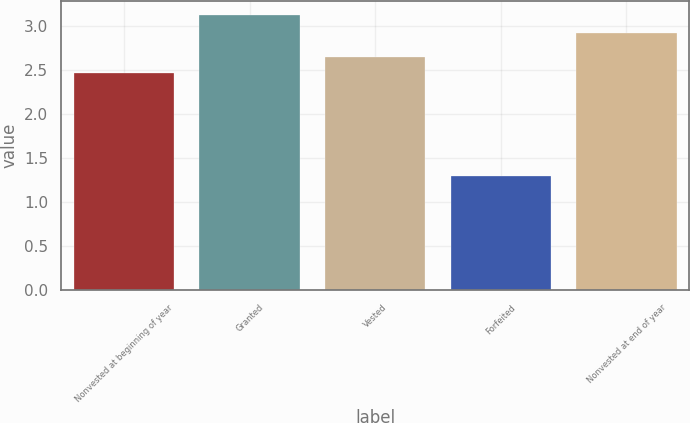Convert chart. <chart><loc_0><loc_0><loc_500><loc_500><bar_chart><fcel>Nonvested at beginning of year<fcel>Granted<fcel>Vested<fcel>Forfeited<fcel>Nonvested at end of year<nl><fcel>2.47<fcel>3.13<fcel>2.65<fcel>1.3<fcel>2.92<nl></chart> 